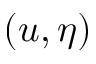Convert formula to latex. <formula><loc_0><loc_0><loc_500><loc_500>( u , \eta )</formula> 